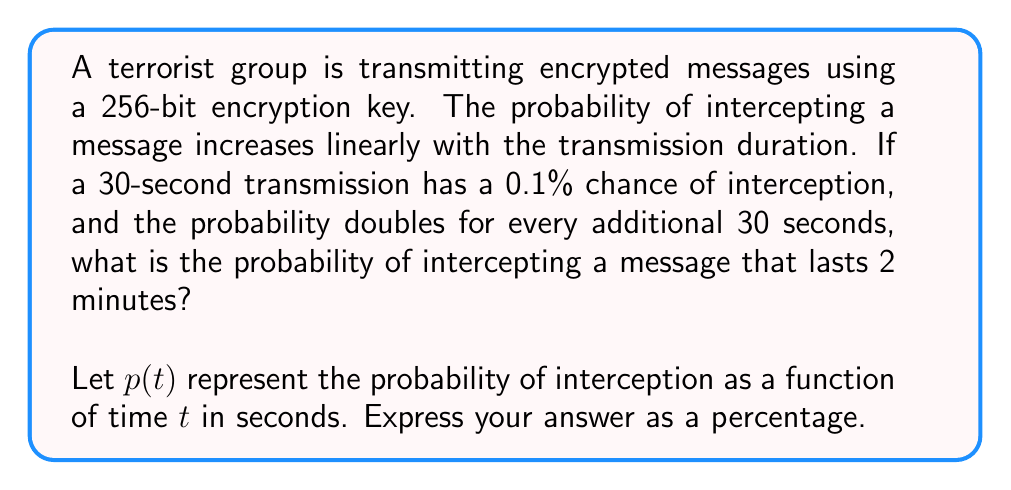Teach me how to tackle this problem. 1) First, let's establish the initial condition:
   $p(30) = 0.1\%$ or $0.001$ in decimal form

2) We're told that the probability doubles every 30 seconds. This suggests an exponential growth function:
   $p(t) = 0.001 \cdot 2^{\frac{t-30}{30}}$

3) We need to find $p(120)$ as the transmission lasts 2 minutes (120 seconds):
   $p(120) = 0.001 \cdot 2^{\frac{120-30}{30}}$

4) Simplify the exponent:
   $p(120) = 0.001 \cdot 2^3$

5) Calculate:
   $p(120) = 0.001 \cdot 8 = 0.008$

6) Convert to percentage:
   $0.008 \cdot 100\% = 0.8\%$
Answer: 0.8% 